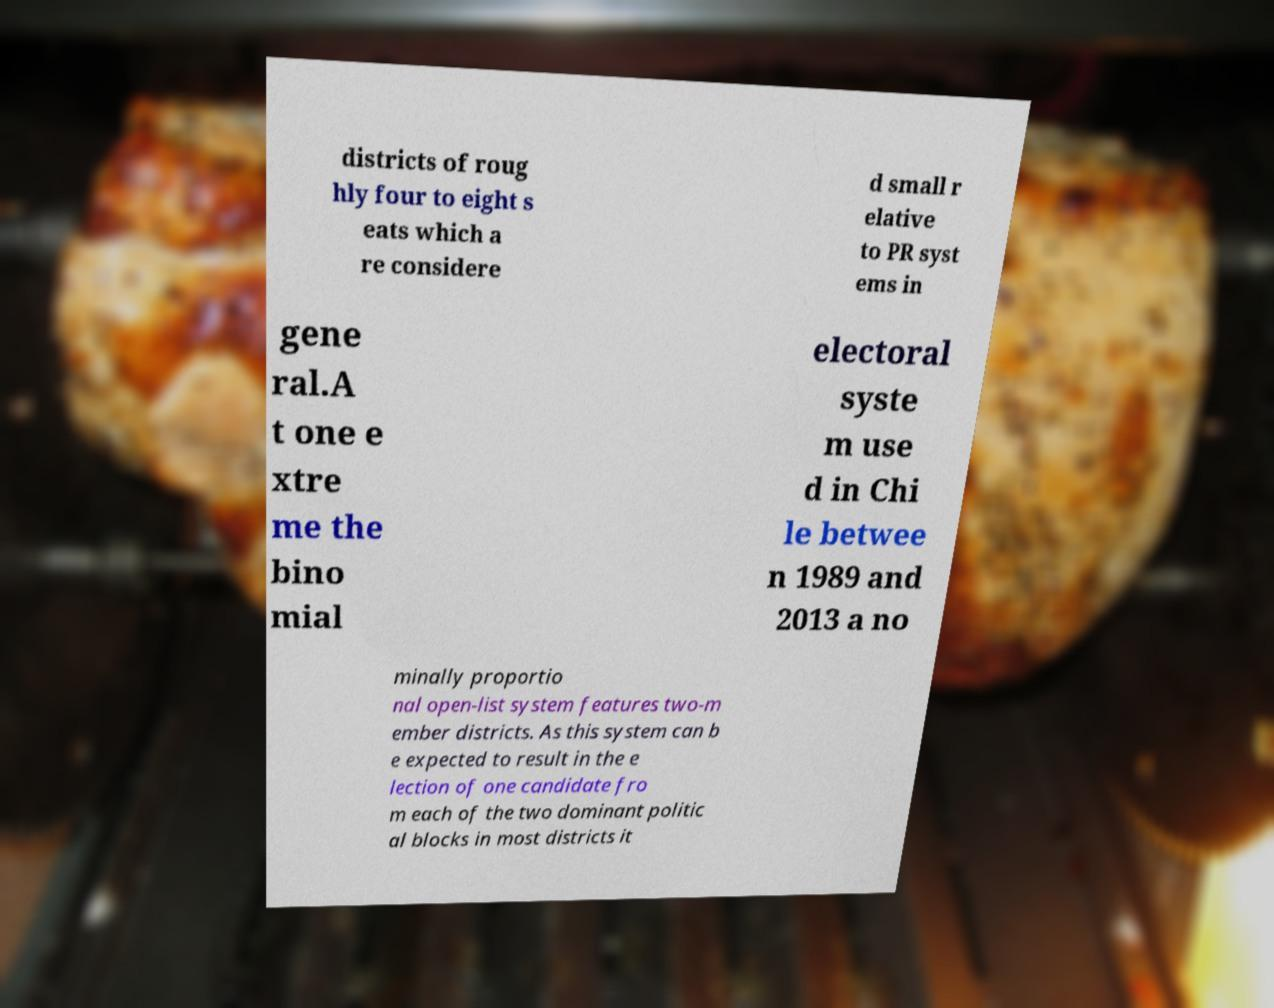I need the written content from this picture converted into text. Can you do that? districts of roug hly four to eight s eats which a re considere d small r elative to PR syst ems in gene ral.A t one e xtre me the bino mial electoral syste m use d in Chi le betwee n 1989 and 2013 a no minally proportio nal open-list system features two-m ember districts. As this system can b e expected to result in the e lection of one candidate fro m each of the two dominant politic al blocks in most districts it 